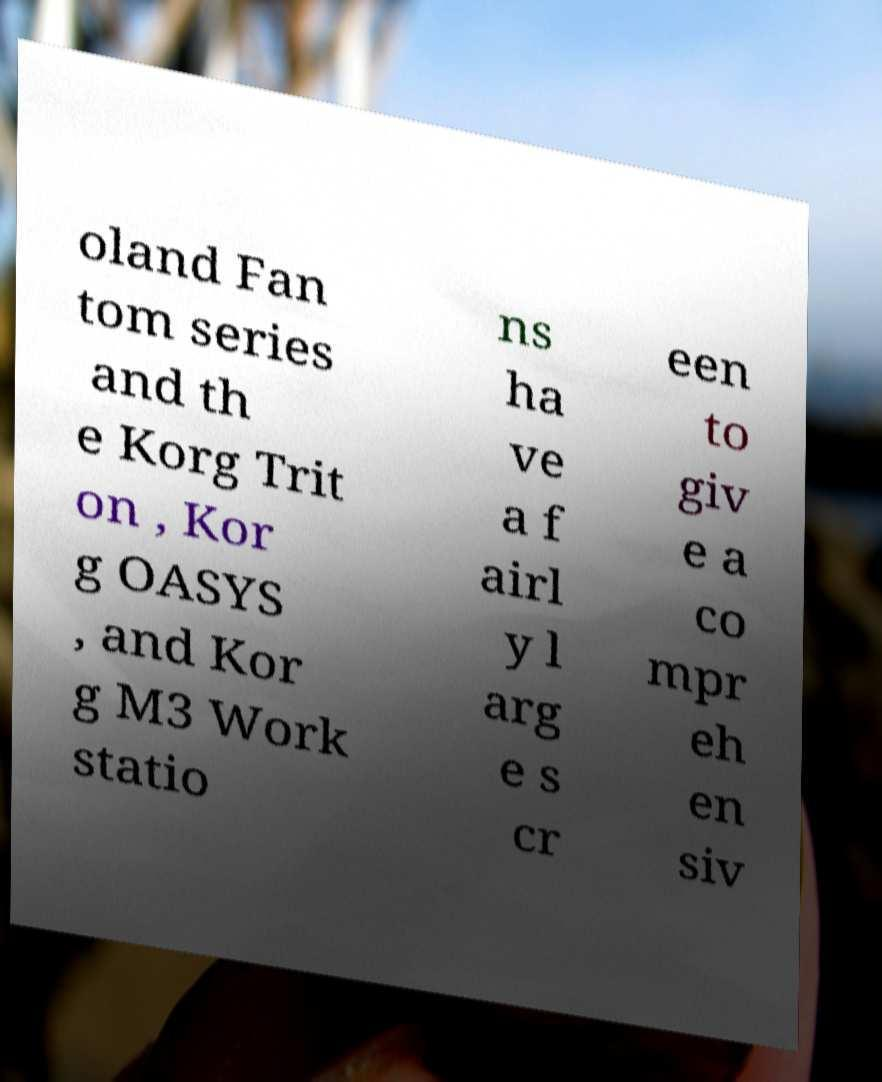Can you read and provide the text displayed in the image?This photo seems to have some interesting text. Can you extract and type it out for me? oland Fan tom series and th e Korg Trit on , Kor g OASYS , and Kor g M3 Work statio ns ha ve a f airl y l arg e s cr een to giv e a co mpr eh en siv 